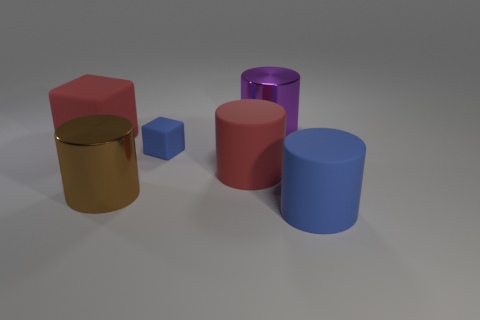Is the color of the small cube the same as the shiny cylinder behind the big block?
Offer a very short reply. No. Are there more blue rubber blocks to the right of the tiny rubber thing than big blue rubber cylinders?
Offer a terse response. No. What number of red rubber things are to the right of the large metal cylinder behind the big rubber cylinder that is behind the large brown object?
Your answer should be very brief. 0. Does the blue object to the right of the small blue cube have the same shape as the big purple object?
Your answer should be very brief. Yes. There is a cylinder behind the small cube; what is it made of?
Provide a short and direct response. Metal. There is a big thing that is both behind the blue matte block and in front of the big purple object; what shape is it?
Offer a terse response. Cube. What is the material of the large red block?
Offer a very short reply. Rubber. What number of spheres are gray shiny things or brown objects?
Your answer should be compact. 0. Are the tiny blue thing and the purple cylinder made of the same material?
Make the answer very short. No. There is a purple thing that is the same shape as the big brown thing; what size is it?
Provide a short and direct response. Large. 